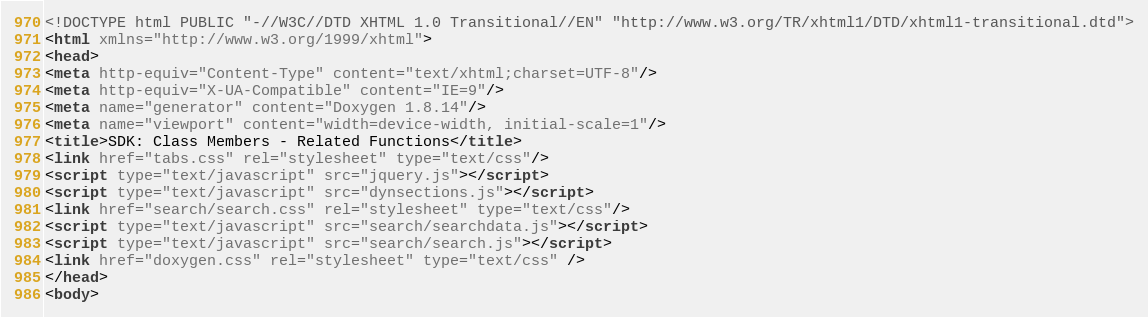<code> <loc_0><loc_0><loc_500><loc_500><_HTML_><!DOCTYPE html PUBLIC "-//W3C//DTD XHTML 1.0 Transitional//EN" "http://www.w3.org/TR/xhtml1/DTD/xhtml1-transitional.dtd">
<html xmlns="http://www.w3.org/1999/xhtml">
<head>
<meta http-equiv="Content-Type" content="text/xhtml;charset=UTF-8"/>
<meta http-equiv="X-UA-Compatible" content="IE=9"/>
<meta name="generator" content="Doxygen 1.8.14"/>
<meta name="viewport" content="width=device-width, initial-scale=1"/>
<title>SDK: Class Members - Related Functions</title>
<link href="tabs.css" rel="stylesheet" type="text/css"/>
<script type="text/javascript" src="jquery.js"></script>
<script type="text/javascript" src="dynsections.js"></script>
<link href="search/search.css" rel="stylesheet" type="text/css"/>
<script type="text/javascript" src="search/searchdata.js"></script>
<script type="text/javascript" src="search/search.js"></script>
<link href="doxygen.css" rel="stylesheet" type="text/css" />
</head>
<body></code> 